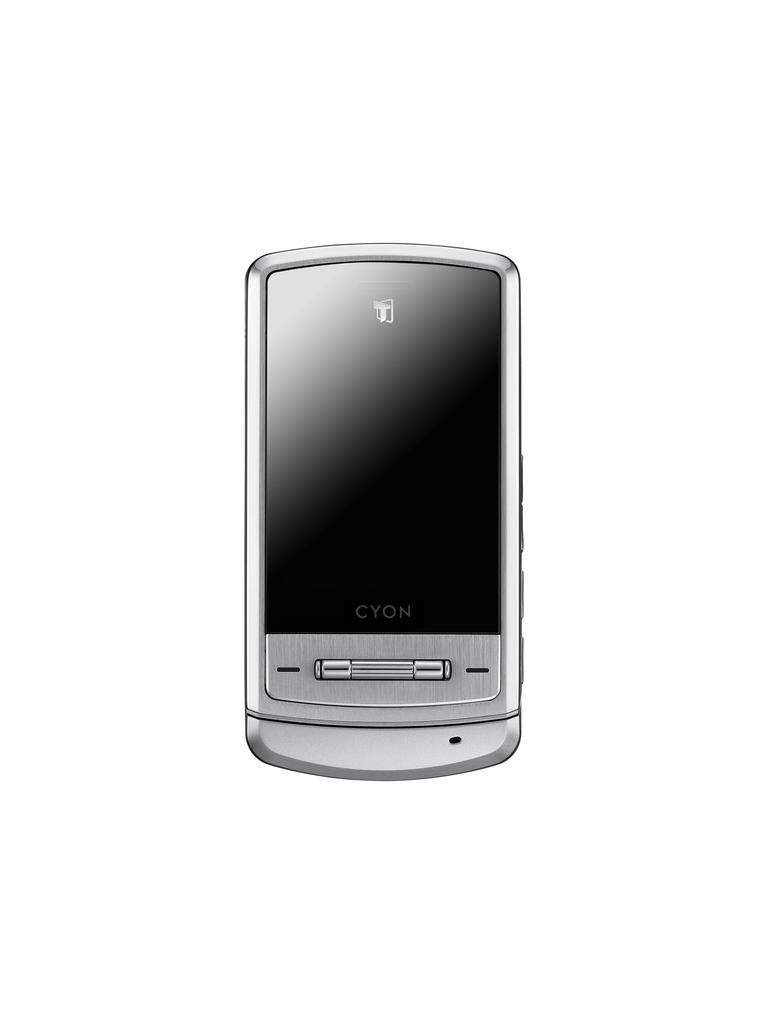<image>
Provide a brief description of the given image. cyon brand cell phone that is the color silver turned off 